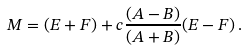<formula> <loc_0><loc_0><loc_500><loc_500>M = ( E + F ) + c \frac { ( A - B ) } { ( A + B ) } ( E - F ) \, .</formula> 